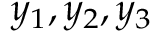<formula> <loc_0><loc_0><loc_500><loc_500>y _ { 1 } , y _ { 2 } , y _ { 3 }</formula> 